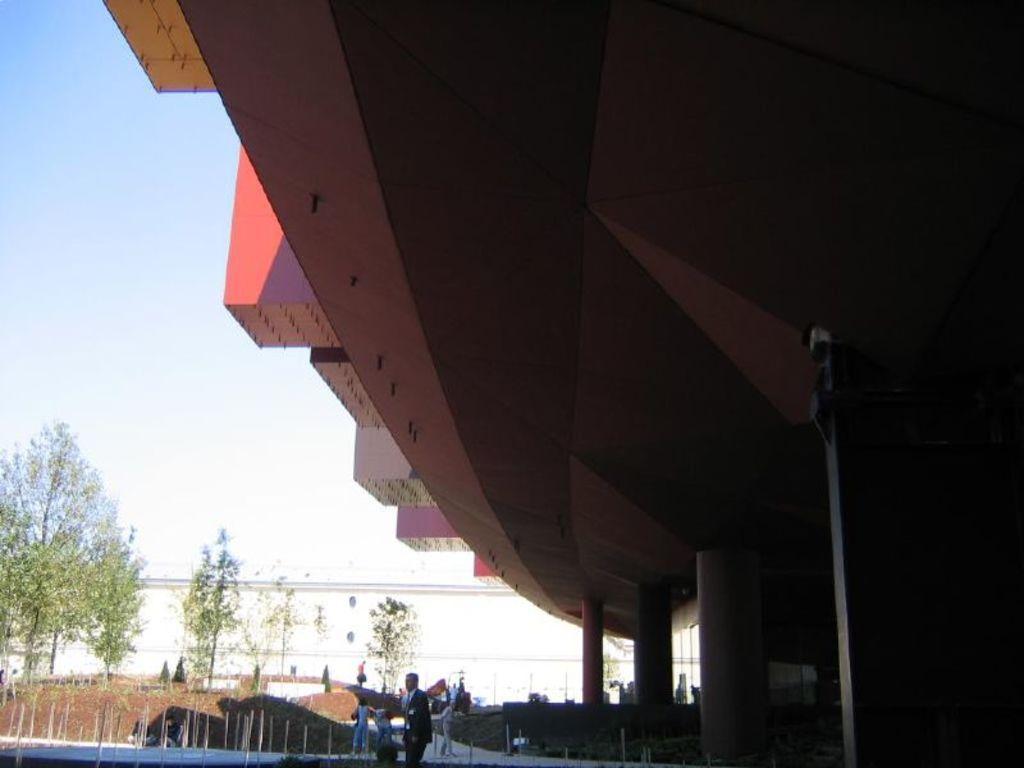Could you give a brief overview of what you see in this image? In this image there is a building at right side of this image and there are some trees at left side of this image and there are some persons standing in middle of this image. There is a sky at top of this image. 